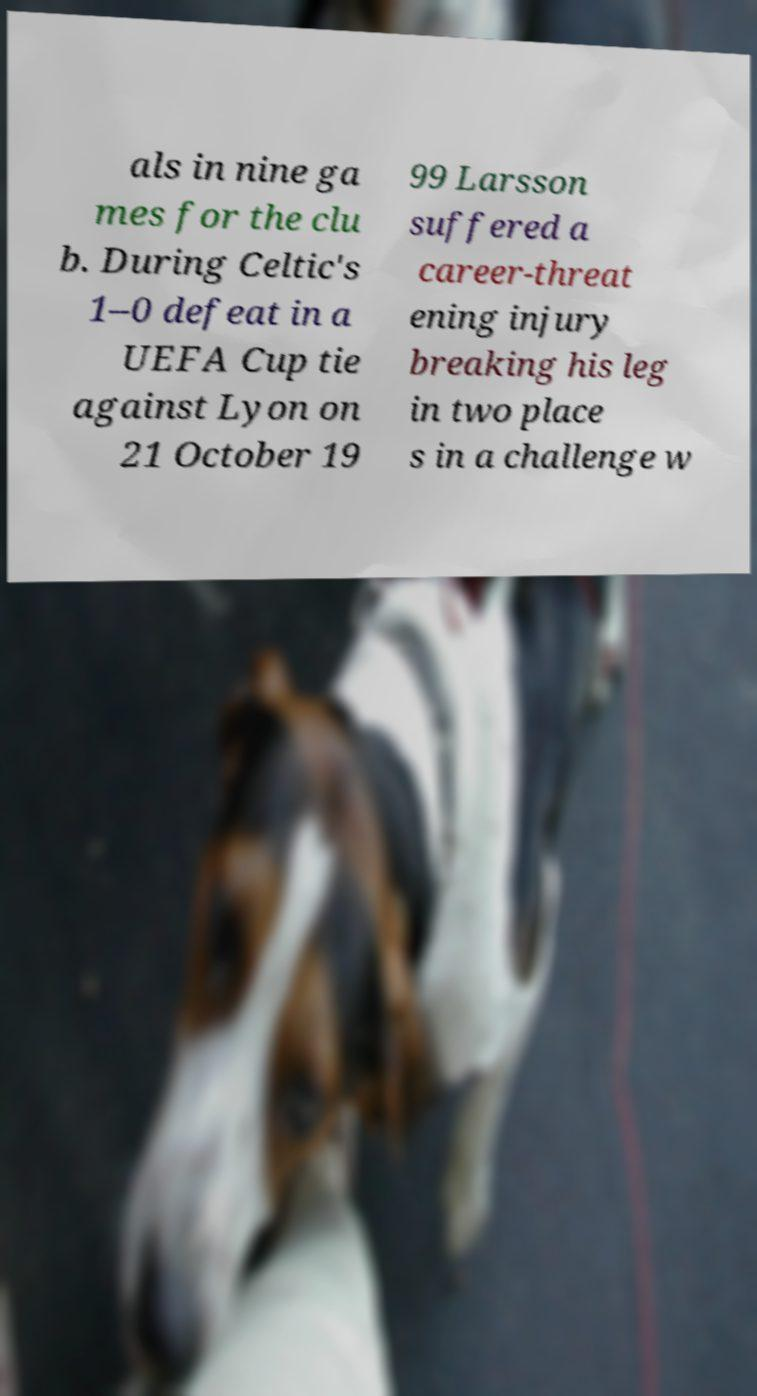Could you extract and type out the text from this image? als in nine ga mes for the clu b. During Celtic's 1–0 defeat in a UEFA Cup tie against Lyon on 21 October 19 99 Larsson suffered a career-threat ening injury breaking his leg in two place s in a challenge w 